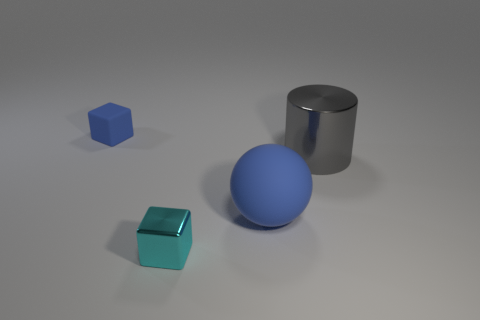Add 2 big blue rubber balls. How many objects exist? 6 Subtract all balls. How many objects are left? 3 Subtract 0 red spheres. How many objects are left? 4 Subtract all metallic things. Subtract all large gray matte balls. How many objects are left? 2 Add 2 tiny blue cubes. How many tiny blue cubes are left? 3 Add 1 tiny yellow rubber objects. How many tiny yellow rubber objects exist? 1 